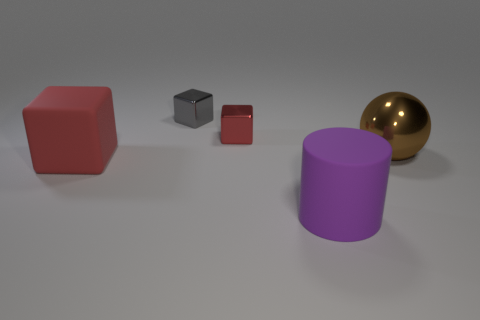How big is the thing that is both behind the large purple cylinder and right of the small red block?
Offer a terse response. Large. There is a red matte thing; what shape is it?
Offer a terse response. Cube. Are there any other things that are the same size as the rubber cylinder?
Your answer should be very brief. Yes. Are there more red rubber blocks to the right of the red matte object than big brown shiny spheres?
Your response must be concise. No. There is a tiny object in front of the small cube behind the red thing behind the brown metal thing; what is its shape?
Offer a terse response. Cube. There is a red block that is in front of the brown metal thing; is its size the same as the large metal ball?
Offer a terse response. Yes. What is the shape of the metallic object that is in front of the small gray object and to the left of the big purple thing?
Make the answer very short. Cube. Do the big cylinder and the tiny shiny cube to the right of the gray metallic cube have the same color?
Ensure brevity in your answer.  No. There is a large thing to the right of the rubber object that is on the right side of the red thing that is right of the big rubber block; what is its color?
Provide a short and direct response. Brown. The large thing that is the same shape as the tiny gray thing is what color?
Offer a very short reply. Red. 